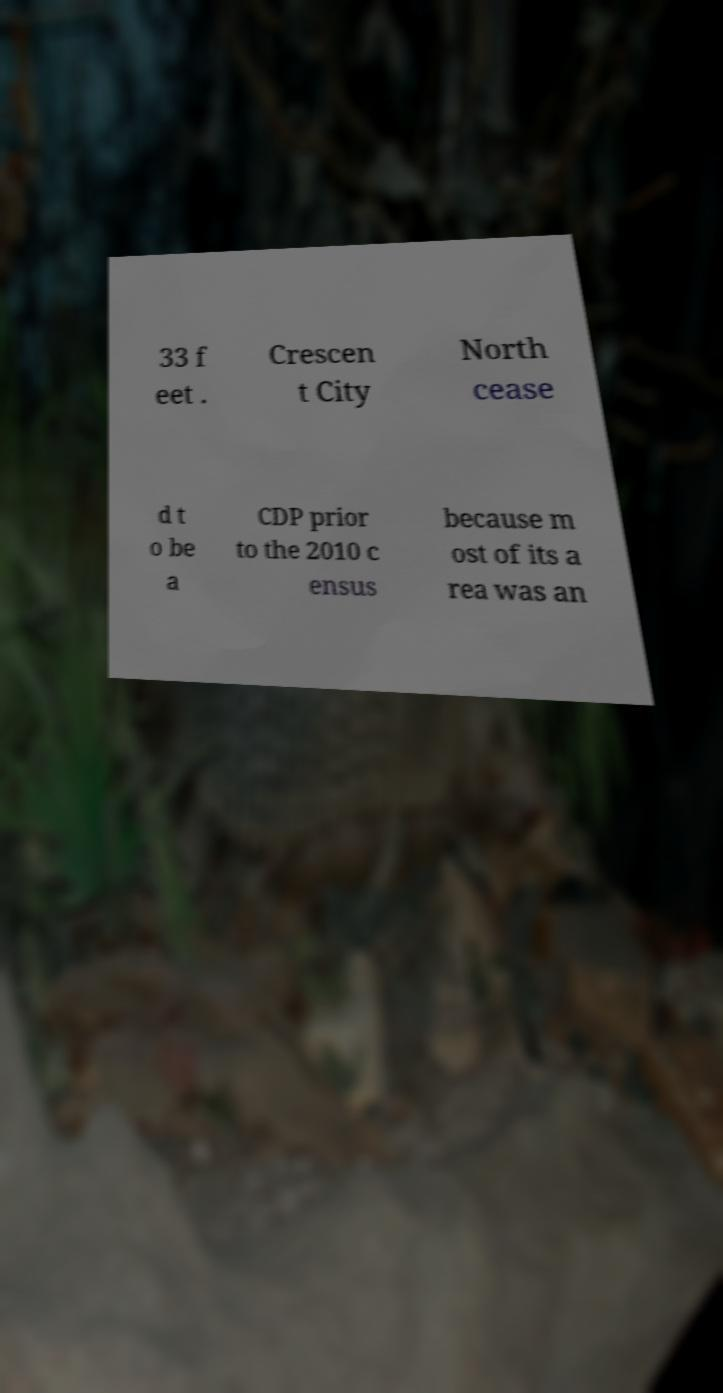Please read and relay the text visible in this image. What does it say? 33 f eet . Crescen t City North cease d t o be a CDP prior to the 2010 c ensus because m ost of its a rea was an 